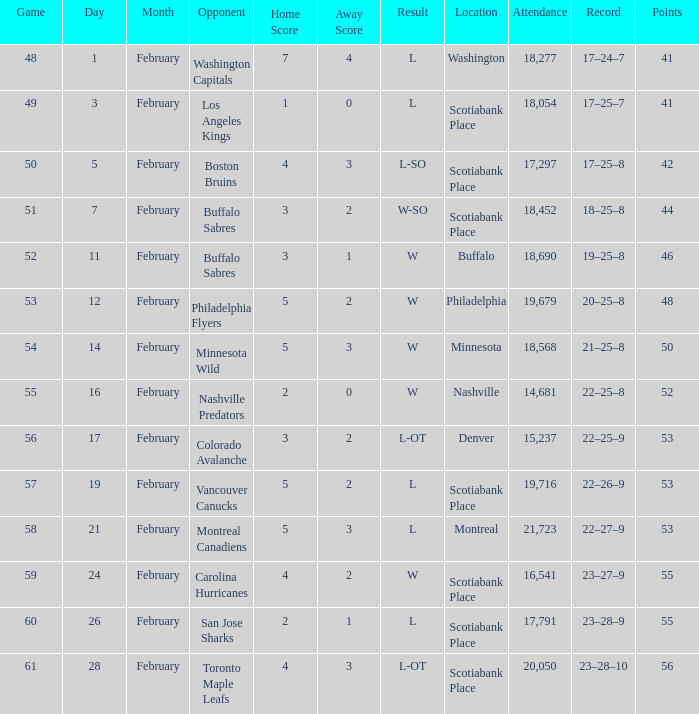What average game was held on february 24 and has an attendance smaller than 16,541? None. 